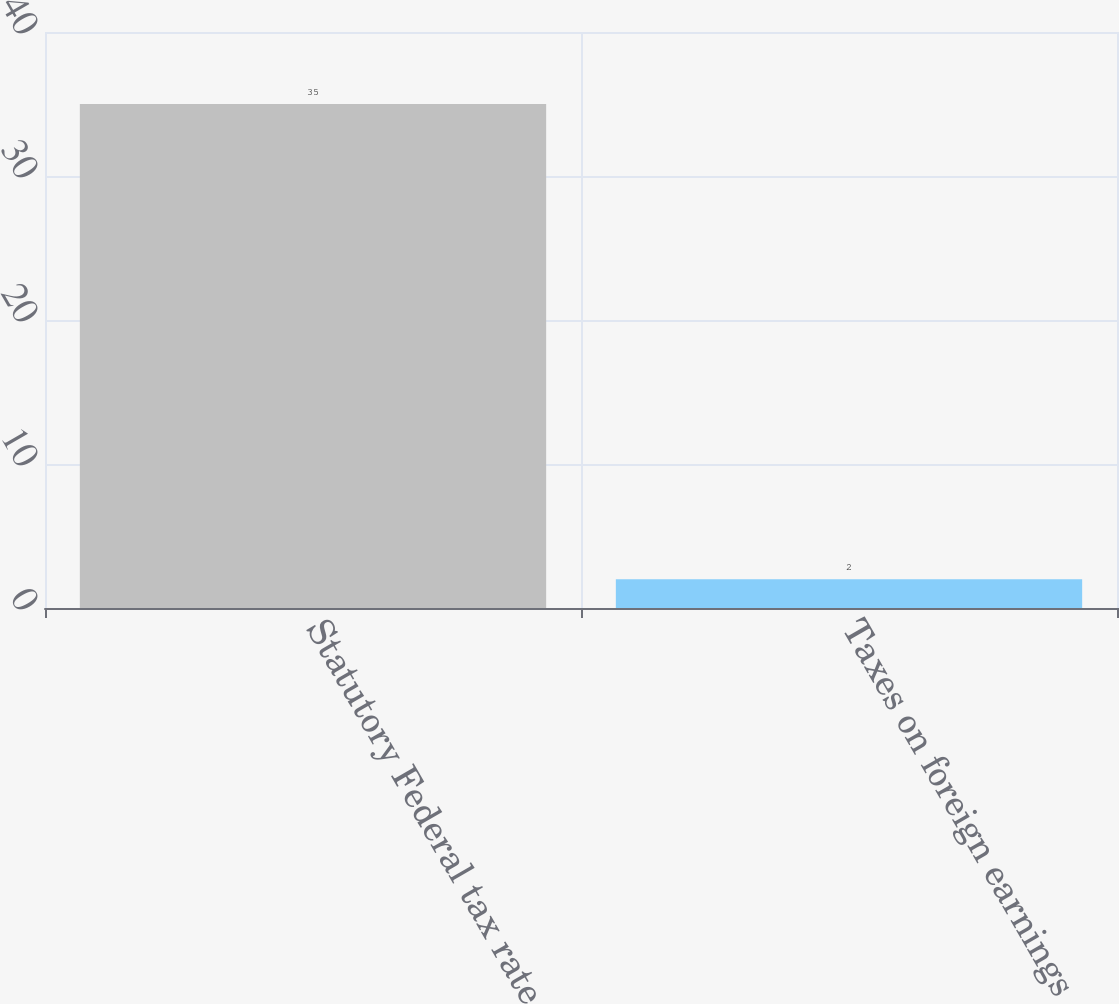<chart> <loc_0><loc_0><loc_500><loc_500><bar_chart><fcel>Statutory Federal tax rate<fcel>Taxes on foreign earnings<nl><fcel>35<fcel>2<nl></chart> 